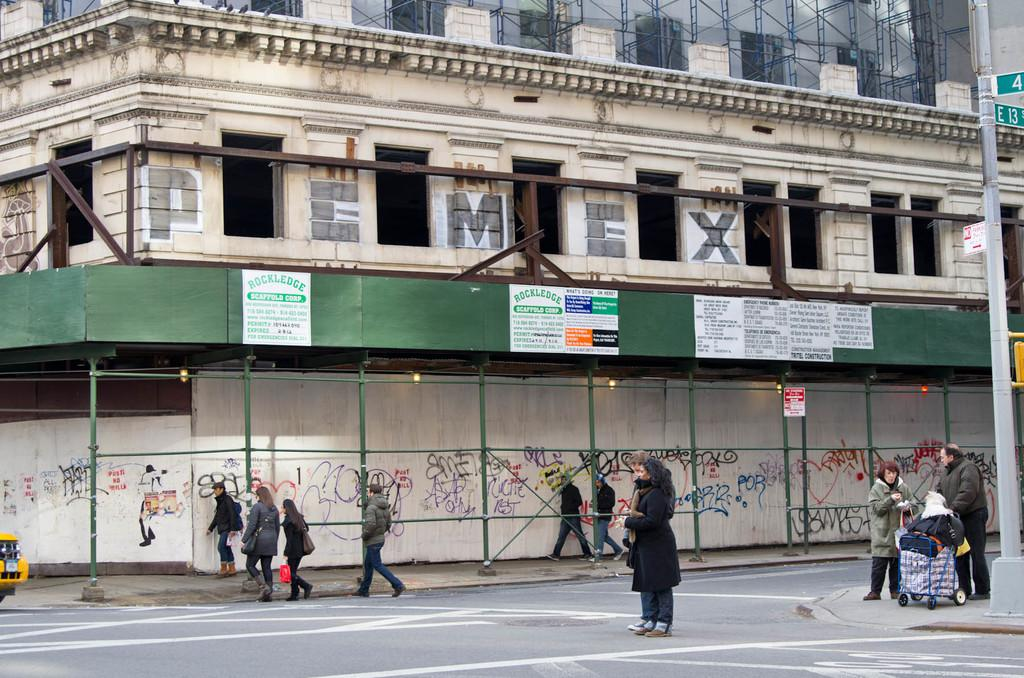<image>
Render a clear and concise summary of the photo. A white building that says "Pemex" has green scaffolding around it that says "Rockledge Scaffold Corp." 